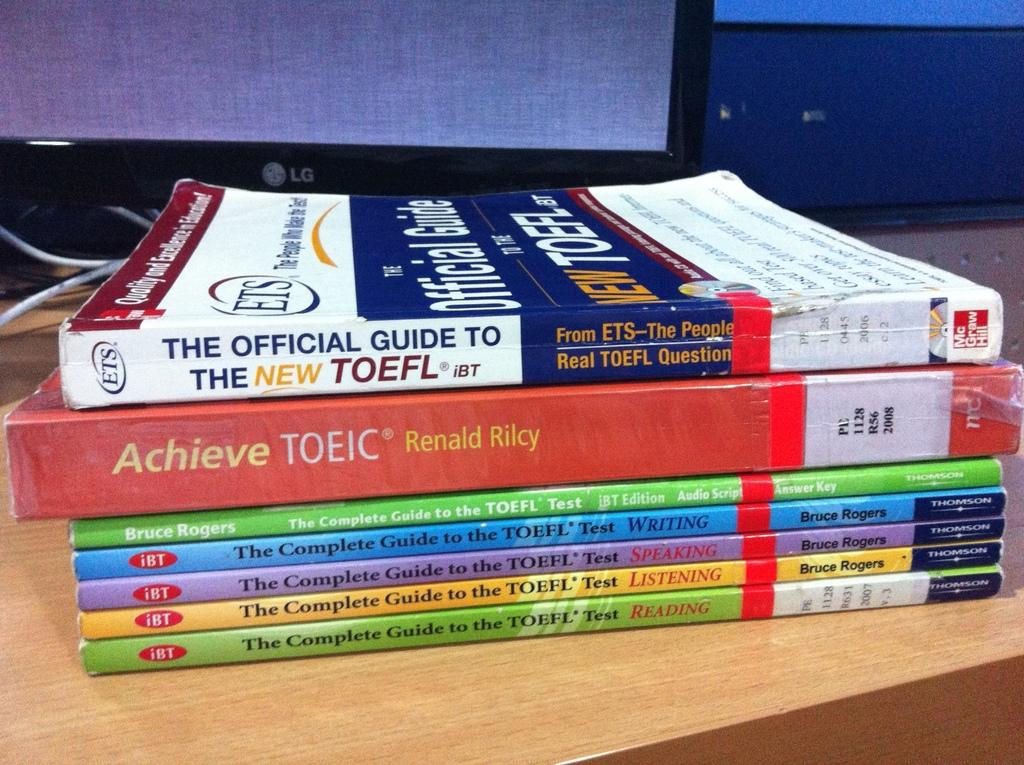<image>
Write a terse but informative summary of the picture. A stack of books and the red book says "achieve". 